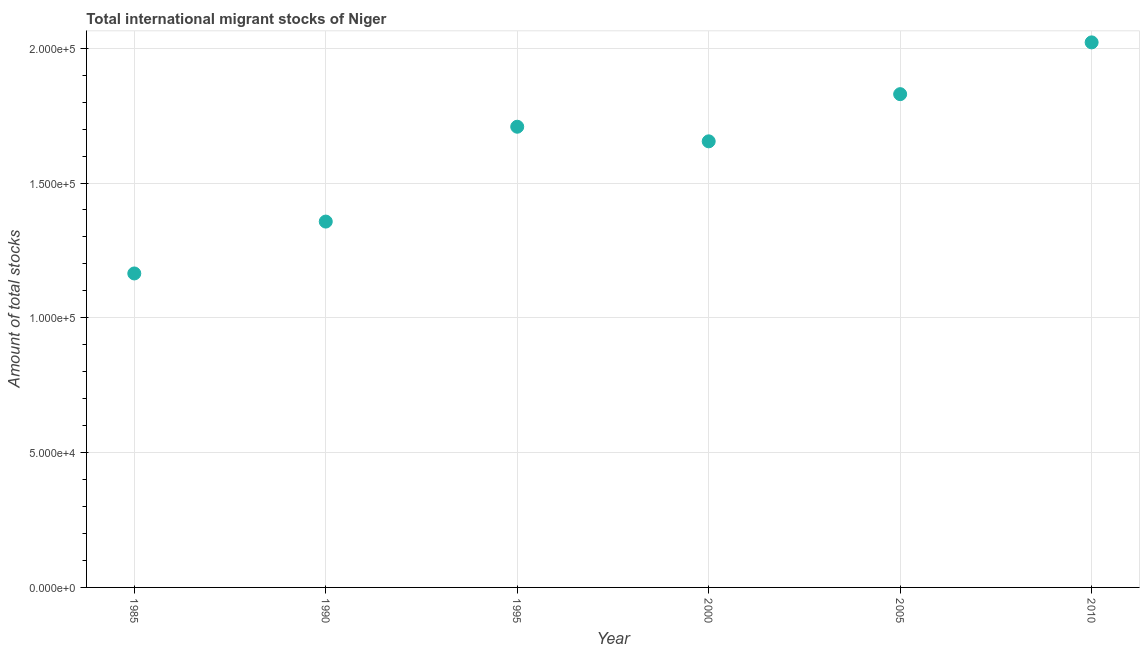What is the total number of international migrant stock in 2005?
Provide a succinct answer. 1.83e+05. Across all years, what is the maximum total number of international migrant stock?
Your answer should be compact. 2.02e+05. Across all years, what is the minimum total number of international migrant stock?
Ensure brevity in your answer.  1.16e+05. In which year was the total number of international migrant stock minimum?
Provide a succinct answer. 1985. What is the sum of the total number of international migrant stock?
Make the answer very short. 9.74e+05. What is the difference between the total number of international migrant stock in 1985 and 2000?
Ensure brevity in your answer.  -4.90e+04. What is the average total number of international migrant stock per year?
Your answer should be compact. 1.62e+05. What is the median total number of international migrant stock?
Provide a short and direct response. 1.68e+05. In how many years, is the total number of international migrant stock greater than 140000 ?
Ensure brevity in your answer.  4. What is the ratio of the total number of international migrant stock in 1985 to that in 2000?
Your response must be concise. 0.7. Is the total number of international migrant stock in 1985 less than that in 2010?
Your answer should be very brief. Yes. Is the difference between the total number of international migrant stock in 1990 and 1995 greater than the difference between any two years?
Provide a short and direct response. No. What is the difference between the highest and the second highest total number of international migrant stock?
Your answer should be compact. 1.92e+04. What is the difference between the highest and the lowest total number of international migrant stock?
Your answer should be compact. 8.57e+04. How many dotlines are there?
Ensure brevity in your answer.  1. What is the difference between two consecutive major ticks on the Y-axis?
Offer a terse response. 5.00e+04. Are the values on the major ticks of Y-axis written in scientific E-notation?
Provide a short and direct response. Yes. Does the graph contain any zero values?
Your answer should be very brief. No. What is the title of the graph?
Make the answer very short. Total international migrant stocks of Niger. What is the label or title of the X-axis?
Give a very brief answer. Year. What is the label or title of the Y-axis?
Provide a succinct answer. Amount of total stocks. What is the Amount of total stocks in 1985?
Offer a very short reply. 1.16e+05. What is the Amount of total stocks in 1990?
Make the answer very short. 1.36e+05. What is the Amount of total stocks in 1995?
Offer a terse response. 1.71e+05. What is the Amount of total stocks in 2000?
Offer a very short reply. 1.65e+05. What is the Amount of total stocks in 2005?
Your answer should be very brief. 1.83e+05. What is the Amount of total stocks in 2010?
Keep it short and to the point. 2.02e+05. What is the difference between the Amount of total stocks in 1985 and 1990?
Give a very brief answer. -1.92e+04. What is the difference between the Amount of total stocks in 1985 and 1995?
Your answer should be compact. -5.44e+04. What is the difference between the Amount of total stocks in 1985 and 2000?
Give a very brief answer. -4.90e+04. What is the difference between the Amount of total stocks in 1985 and 2005?
Offer a very short reply. -6.65e+04. What is the difference between the Amount of total stocks in 1985 and 2010?
Give a very brief answer. -8.57e+04. What is the difference between the Amount of total stocks in 1990 and 1995?
Ensure brevity in your answer.  -3.52e+04. What is the difference between the Amount of total stocks in 1990 and 2000?
Make the answer very short. -2.98e+04. What is the difference between the Amount of total stocks in 1990 and 2005?
Your response must be concise. -4.73e+04. What is the difference between the Amount of total stocks in 1990 and 2010?
Make the answer very short. -6.65e+04. What is the difference between the Amount of total stocks in 1995 and 2000?
Your answer should be compact. 5416. What is the difference between the Amount of total stocks in 1995 and 2005?
Provide a short and direct response. -1.21e+04. What is the difference between the Amount of total stocks in 1995 and 2010?
Make the answer very short. -3.13e+04. What is the difference between the Amount of total stocks in 2000 and 2005?
Offer a terse response. -1.75e+04. What is the difference between the Amount of total stocks in 2000 and 2010?
Offer a very short reply. -3.67e+04. What is the difference between the Amount of total stocks in 2005 and 2010?
Your response must be concise. -1.92e+04. What is the ratio of the Amount of total stocks in 1985 to that in 1990?
Offer a terse response. 0.86. What is the ratio of the Amount of total stocks in 1985 to that in 1995?
Your answer should be compact. 0.68. What is the ratio of the Amount of total stocks in 1985 to that in 2000?
Keep it short and to the point. 0.7. What is the ratio of the Amount of total stocks in 1985 to that in 2005?
Provide a short and direct response. 0.64. What is the ratio of the Amount of total stocks in 1985 to that in 2010?
Your answer should be very brief. 0.58. What is the ratio of the Amount of total stocks in 1990 to that in 1995?
Keep it short and to the point. 0.79. What is the ratio of the Amount of total stocks in 1990 to that in 2000?
Offer a terse response. 0.82. What is the ratio of the Amount of total stocks in 1990 to that in 2005?
Offer a very short reply. 0.74. What is the ratio of the Amount of total stocks in 1990 to that in 2010?
Your answer should be compact. 0.67. What is the ratio of the Amount of total stocks in 1995 to that in 2000?
Your response must be concise. 1.03. What is the ratio of the Amount of total stocks in 1995 to that in 2005?
Your response must be concise. 0.93. What is the ratio of the Amount of total stocks in 1995 to that in 2010?
Keep it short and to the point. 0.84. What is the ratio of the Amount of total stocks in 2000 to that in 2005?
Provide a succinct answer. 0.9. What is the ratio of the Amount of total stocks in 2000 to that in 2010?
Offer a very short reply. 0.82. What is the ratio of the Amount of total stocks in 2005 to that in 2010?
Provide a succinct answer. 0.91. 